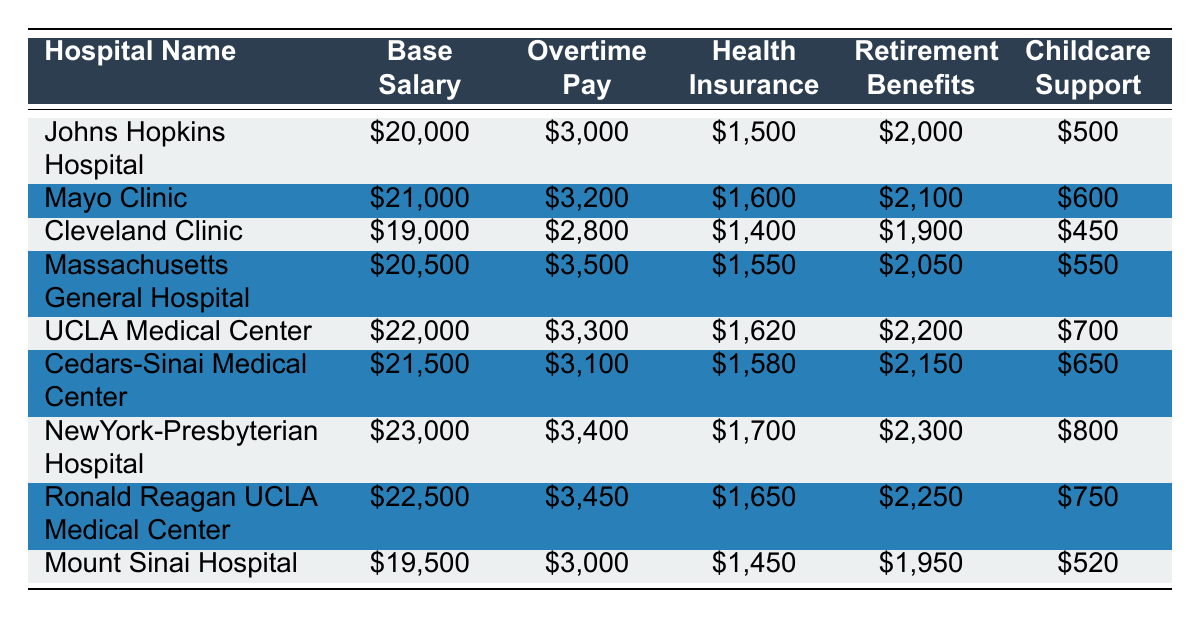What is the base salary for NewYork-Presbyterian Hospital? The base salary for NewYork-Presbyterian Hospital is directly listed in the table as $23,000.
Answer: $23,000 How much is the childcare support at UCLA Medical Center? The childcare support amount for UCLA Medical Center is provided in the table as $700.
Answer: $700 Which hospital offers the highest total salary and benefits? To find the total, we need to add the Base Salary, Overtime Pay, Health Insurance, Retirement Benefits, and Childcare Support for each hospital. For NewYork-Presbyterian Hospital, this totals to $23,000 + $3,400 + $1,700 + $2,300 + $800 = $31,200, which is the highest compared to other hospitals.
Answer: NewYork-Presbyterian Hospital Which hospital has the lowest base salary? By comparing the base salaries from the table, Cleveland Clinic has the lowest base salary at $19,000.
Answer: Cleveland Clinic What is the average retirement benefit for all hospitals? To find the average retirement benefit, we sum the retirement benefits from all hospitals: $2,000 + $2,100 + $1,900 + $2,050 + $2,200 + $2,150 + $2,300 + $2,250 + $1,950 = $18,000. There are 9 hospitals, so we divide: $18,000 / 9 = $2,000.
Answer: $2,000 Is the health insurance at Massachusetts General Hospital higher than that at Mount Sinai Hospital? The health insurance at Massachusetts General Hospital is $1,550, while at Mount Sinai Hospital it is $1,450, making Massachusetts General Hospital higher by $100.
Answer: Yes If a nurse works 5 hours of overtime at the Massachusetts General Hospital, what would the total compensation for those hours be? Overtime pay for Massachusetts General Hospital is $3,500, which translates to an average of $3,500 / (5 x 0.5) = $350 per hour. Therefore, for 5 hours of overtime, the total compensation would be 5 x $350 = $1,750.
Answer: $1,750 What is the difference in childcare support between the hospital with the highest and the lowest childcare support? NewYork-Presbyterian Hospital has the highest childcare support at $800, and Cleveland Clinic has the lowest at $450. The difference is $800 - $450 = $350.
Answer: $350 How much total salary and benefits does Cedars-Sinai Medical Center provide compared to Johns Hopkins Hospital? Cedars-Sinai Medical Center totals $21,500 (base) + $3,100 (overtime) + $1,580 (health insurance) + $2,150 (retirement) + $650 (childcare) = $28,080. Johns Hopkins Hospital totals $20,000 + $3,000 + $1,500 + $2,000 + $500 = $27,000. Thus, Cedars-Sinai Medical Center provides $28,080 - $27,000 = $1,080 more in total benefits.
Answer: $1,080 more 